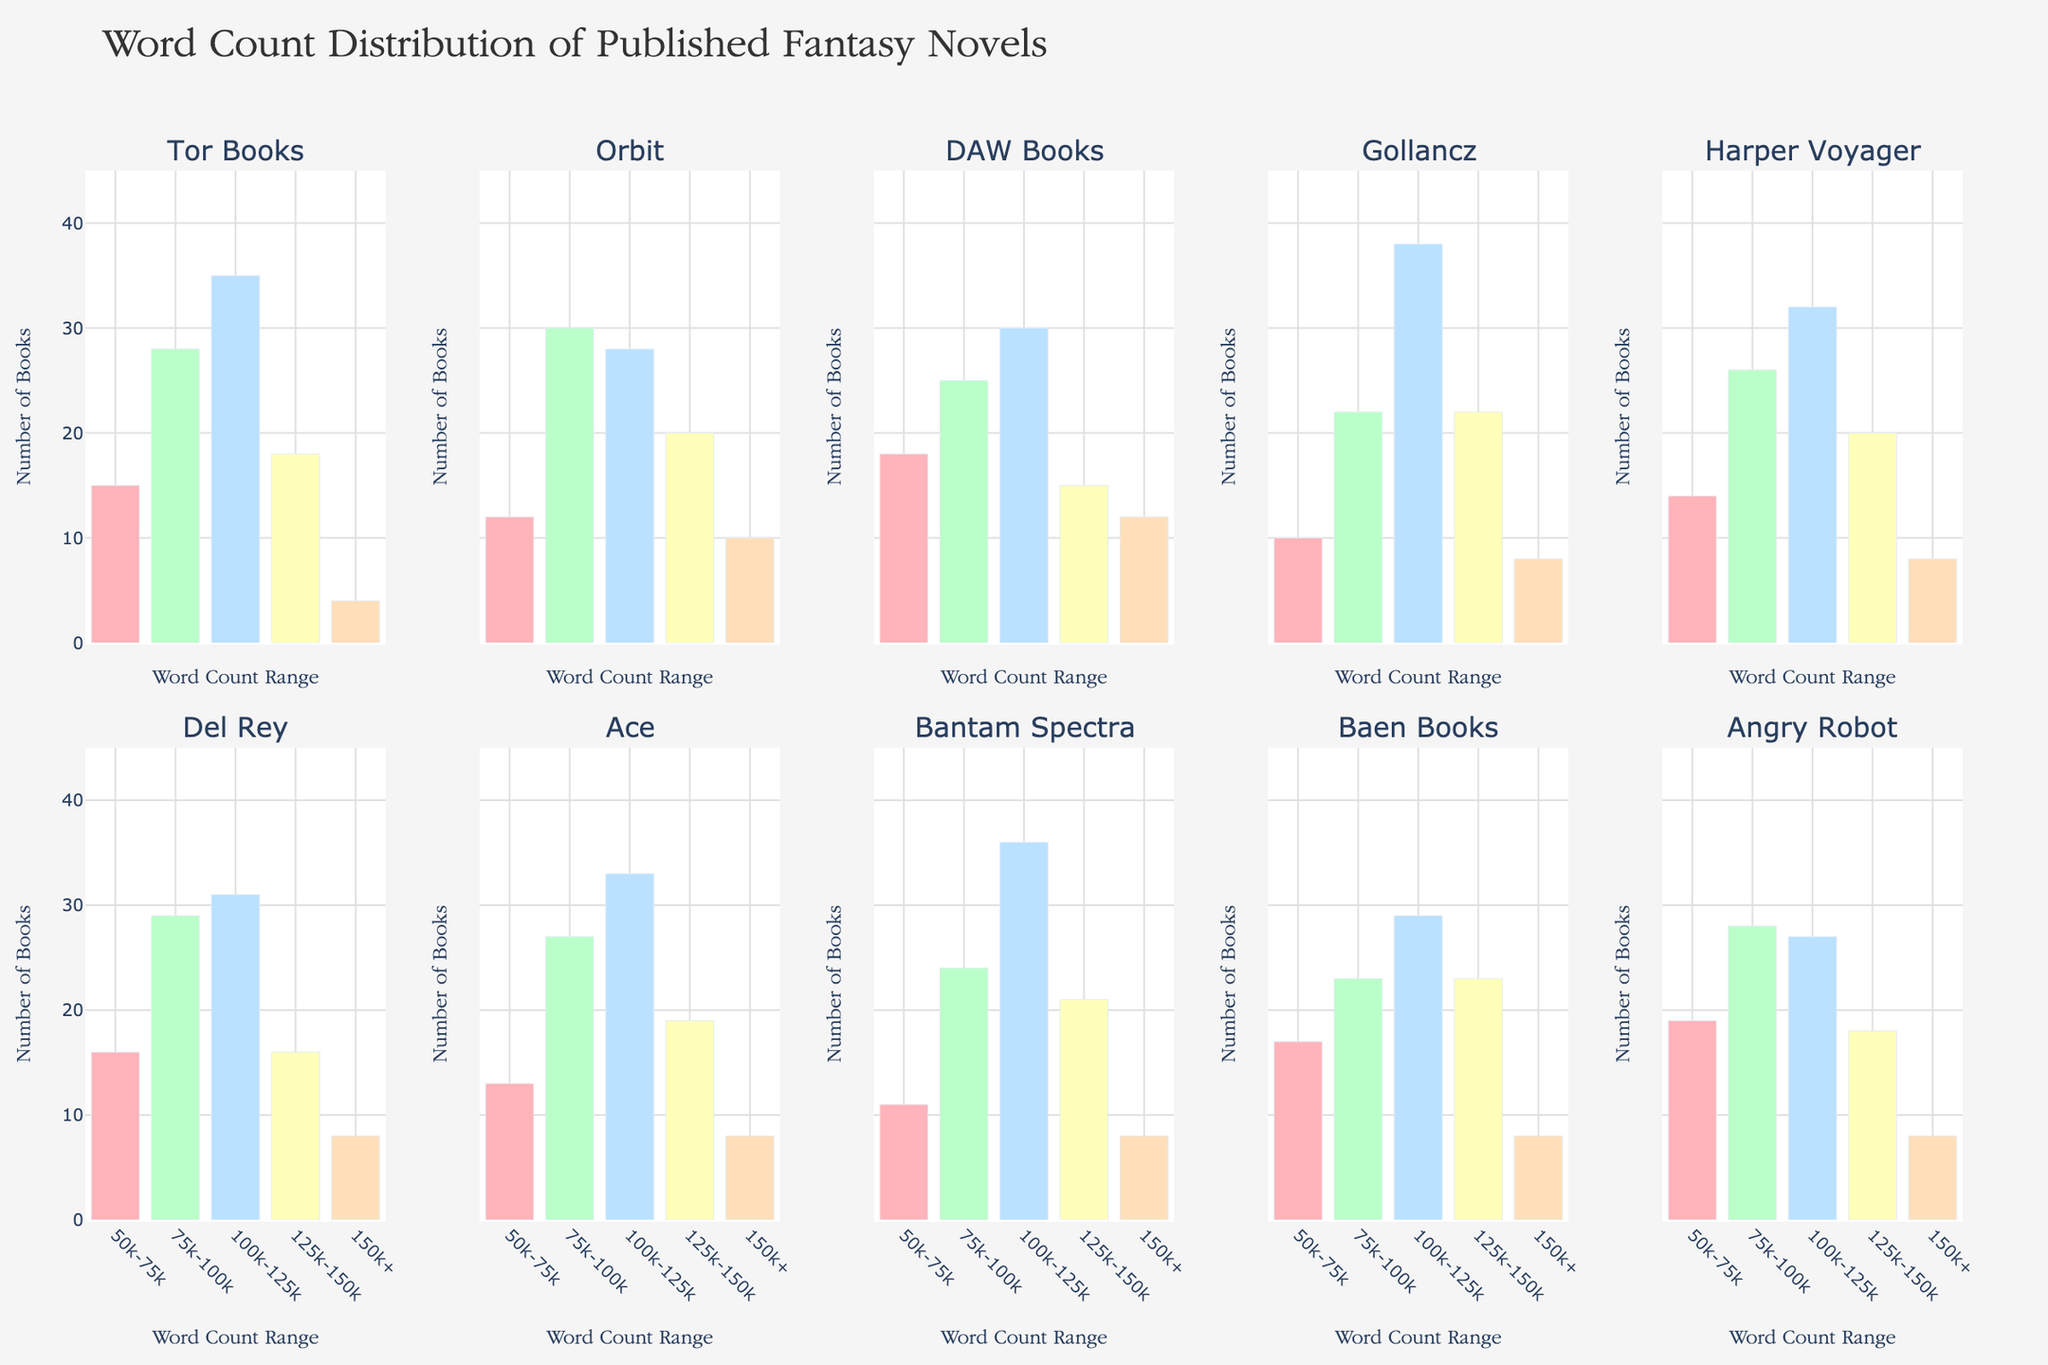How many books does Ace have in the 100k-125k word count range? Look at the subplot for Ace and check the bar corresponding to the 100k-125k word count range. The bar reaches up to 33 books.
Answer: 33 Which publishing house has the fewest books in the 125k-150k range? Compare the bars for the 125k-150k range across all subplots. Tor Books has 18, Orbit has 20, DAW Books has 15, Gollancz has 22, Harper Voyager has 20, Del Rey has 16, Ace has 19, Bantam Spectra has 21, Baen Books has 23, and Angry Robot has 18. DAW Books has the fewest with 15.
Answer: DAW Books What is the total number of books published by Orbit in all word count ranges? Add up the number of books in each word count range for Orbit. They have 12 (50k-75k) + 30 (75k-100k) + 28 (100k-125k) + 20 (125k-150k) + 10 (150k+), which totals 100.
Answer: 100 Between Gollancz and Del Rey, which has more books in the 150k+ range? Check the bars for the 150k+ range for Gollancz and Del Rey in their respective subplots. Both Gollancz and Del Rey have 8 books each in this range.
Answer: The same What is the average number of books in the 75k-100k range across all publishing houses? First, sum the number of books in the 75k-100k range across all subplots: 28 (Tor Books) + 30 (Orbit) + 25 (DAW Books) + 22 (Gollancz) + 26 (Harper Voyager) + 29 (Del Rey) + 27 (Ace) + 24 (Bantam Spectra) + 23 (Baen Books) + 28 (Angry Robot) = 262. Then, divide by the number of publishing houses, which is 10. The average is 262/10 = 26.2.
Answer: 26.2 Which word count range has the highest number of books overall when summed across all publishing houses? Sum the number of books in each word count range across all publishing houses. For 50k-75k: 15 + 12 + 18 + 10 + 14 + 16 + 13 + 11 + 17 + 19 = 145. For 75k-100k: 28 + 30 + 25 + 22 + 26 + 29 + 27 + 24 + 23 + 28 = 262. For 100k-125k: 35 + 28 + 30 + 38 + 32 + 31 + 33 + 36 + 29 + 27 = 319. For 125k-150k: 18 + 20 + 15 + 22 + 20 + 16 + 19 + 21 + 23 + 18 = 192. For 150k+: 4 + 10 + 12 + 8 + 8 + 8 + 8 + 8 + 8 + 8 = 82. The highest is 100k-125k with 319 books.
Answer: 100k-125k What percent of Del Rey's books fall into the 125k-150k range? Del Rey has 16 books in the 125k-150k range out of a total of 16 (50k-75k) + 29 (75k-100k) + 31 (100k-125k) + 16 (125k-150k) + 8 (150k+) = 100 books. The percentage is (16/100) * 100% = 16%.
Answer: 16% How does the number of books in the 50k-75k range for Tor Books compare with Ace? The number of books in the 50k-75k range for Tor Books is 15, while for Ace it is 13. Tor Books has 2 more books than Ace in this range.
Answer: Tor Books has 2 more Which publishing house has the largest number of books in the 100k-125k range? Compare the bars for the 100k-125k range across all subplots. Gollancz has the highest number with 38 books.
Answer: Gollancz 